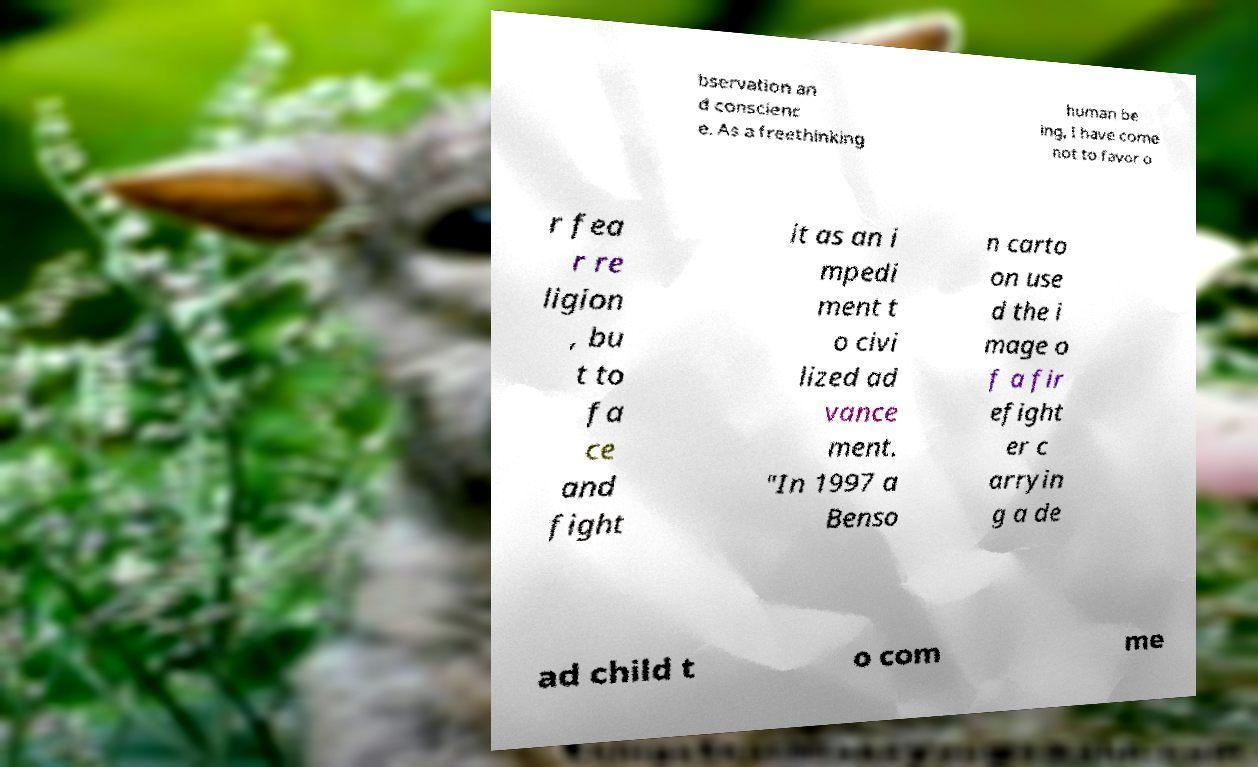Can you accurately transcribe the text from the provided image for me? bservation an d conscienc e. As a freethinking human be ing, I have come not to favor o r fea r re ligion , bu t to fa ce and fight it as an i mpedi ment t o civi lized ad vance ment. "In 1997 a Benso n carto on use d the i mage o f a fir efight er c arryin g a de ad child t o com me 